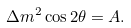Convert formula to latex. <formula><loc_0><loc_0><loc_500><loc_500>\Delta m ^ { 2 } \cos 2 \theta = A .</formula> 